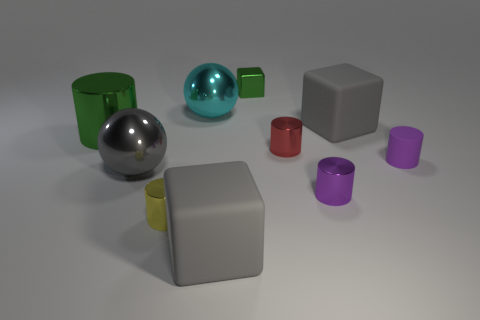There is a gray matte object that is behind the big green metallic object; does it have the same shape as the small shiny object behind the tiny red metal cylinder?
Offer a terse response. Yes. There is a large cylinder; is its color the same as the shiny block to the left of the purple metal thing?
Offer a terse response. Yes. There is a large rubber block on the left side of the metallic cube; is its color the same as the small rubber cylinder?
Make the answer very short. No. What number of objects are metallic things or large gray things that are in front of the small purple metal cylinder?
Offer a very short reply. 8. There is a gray object that is in front of the big cylinder and on the right side of the yellow metal cylinder; what is it made of?
Provide a short and direct response. Rubber. What is the material of the big object that is in front of the purple metal thing?
Give a very brief answer. Rubber. The other large cylinder that is the same material as the red cylinder is what color?
Offer a terse response. Green. There is a tiny purple rubber thing; is it the same shape as the red object on the right side of the yellow shiny cylinder?
Provide a succinct answer. Yes. Are there any red shiny objects to the right of the purple metallic cylinder?
Ensure brevity in your answer.  No. What material is the other thing that is the same color as the tiny rubber thing?
Your response must be concise. Metal. 